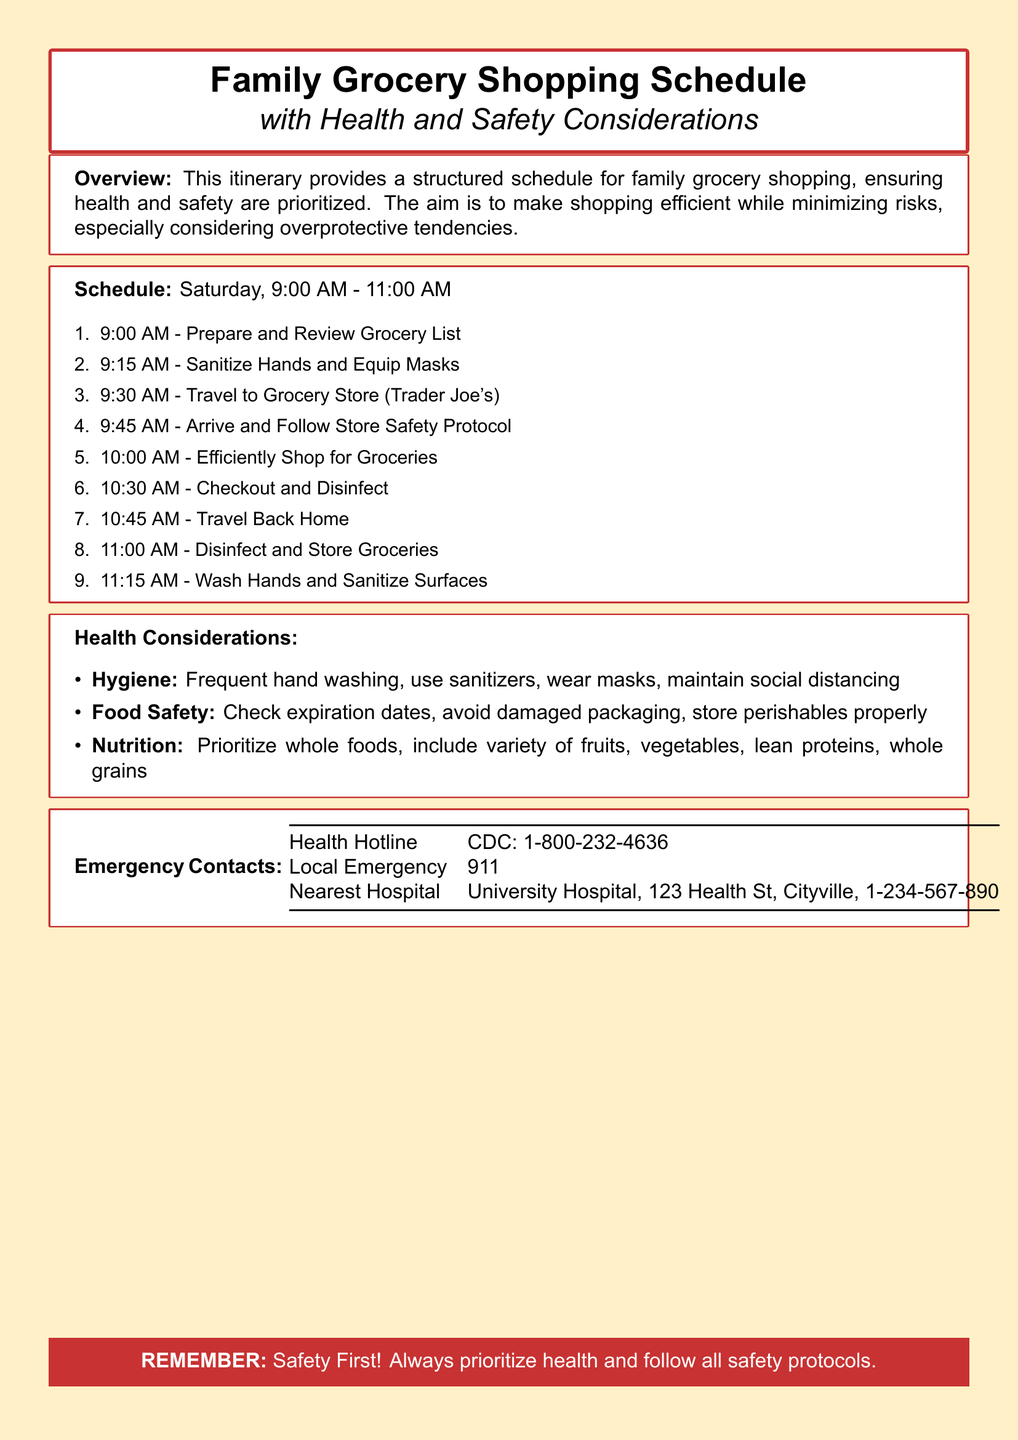What time does shopping start? The shopping starts at 9:00 AM, as listed in the schedule section of the document.
Answer: 9:00 AM What is the first activity before leaving for the grocery store? The first activity is preparing and reviewing the grocery list, which is mentioned in the schedule.
Answer: Prepare and Review Grocery List What safety equipment should be used before shopping? The document specifies that hands should be sanitized and masks equipped before shopping.
Answer: Hands and masks What are the emergency contact numbers listed in the itinerary? The document includes the health hotline, local emergency, and nearest hospital as emergency contacts.
Answer: CDC: 1-800-232-4636, 911, University Hospital, 123 Health St, Cityville How much time is allocated for checkout and disinfecting? Checkout and disinfecting is allocated from 10:30 AM to 10:45 AM, a total of 15 minutes as per the schedule.
Answer: 15 minutes What is one key health consideration mentioned for food safety? The document emphasizes checking expiration dates to ensure food safety.
Answer: Check expiration dates What is the total duration of the grocery shopping schedule? The total duration is from 9:00 AM to 11:15 AM, making it just over 2 hours.
Answer: 2 hours 15 minutes How many health considerations are listed in the itinerary? There are three health considerations mentioned: hygiene, food safety, and nutrition.
Answer: Three What is the last step after arriving back home? The last step mentioned is to disinfect and store groceries after arriving back home.
Answer: Disinfect and Store Groceries 